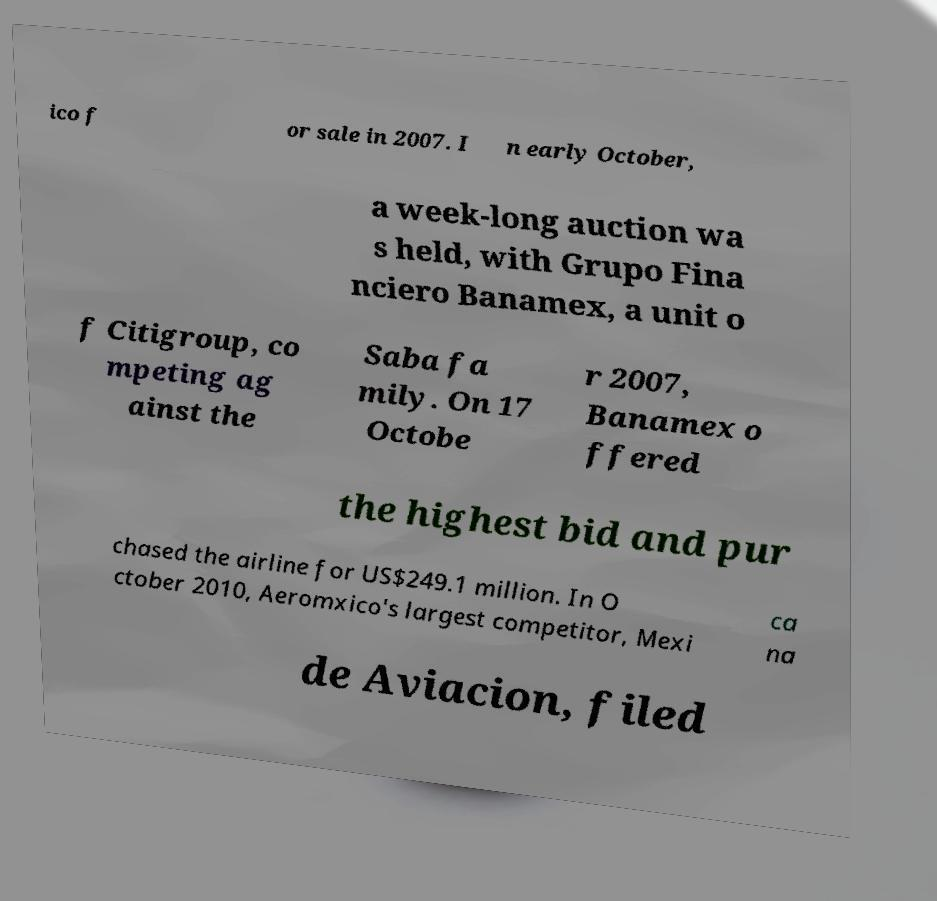There's text embedded in this image that I need extracted. Can you transcribe it verbatim? ico f or sale in 2007. I n early October, a week-long auction wa s held, with Grupo Fina nciero Banamex, a unit o f Citigroup, co mpeting ag ainst the Saba fa mily. On 17 Octobe r 2007, Banamex o ffered the highest bid and pur chased the airline for US$249.1 million. In O ctober 2010, Aeromxico's largest competitor, Mexi ca na de Aviacion, filed 